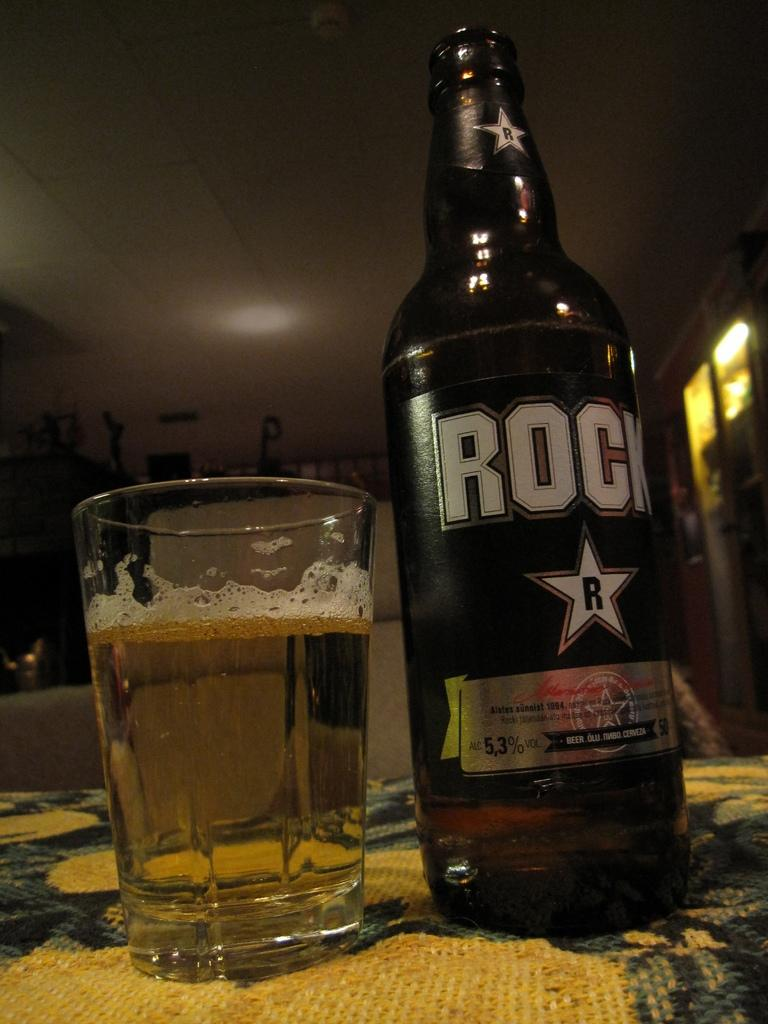<image>
Give a short and clear explanation of the subsequent image. A bottle of Rock Beer sits on a table poured into a glass 